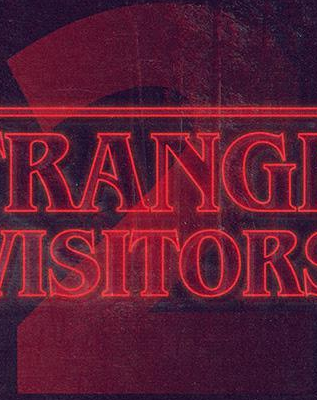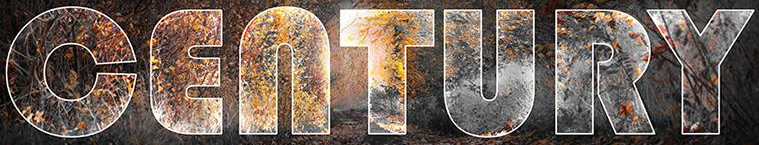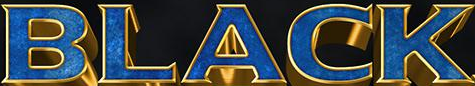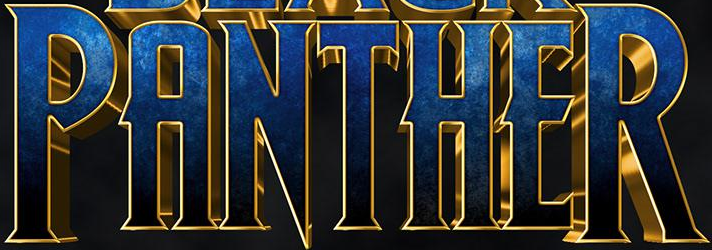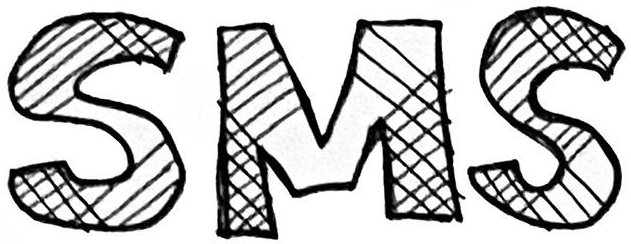What text appears in these images from left to right, separated by a semicolon? 2; CENTURY; BLACK; PANTHER; SMS 